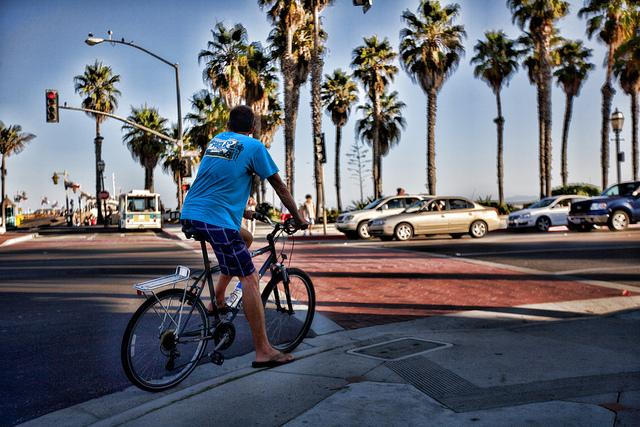What kind of transportation is shown?

Choices:
A) rail
B) water
C) air
D) road road 